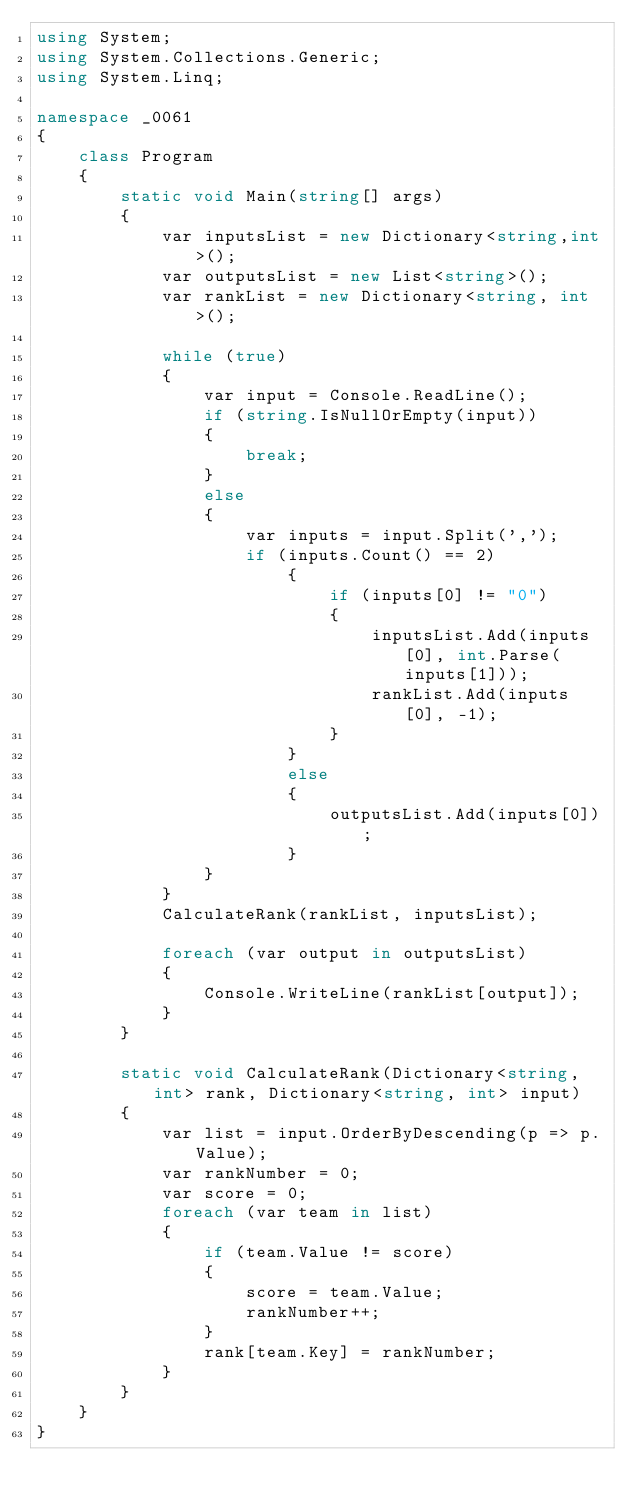Convert code to text. <code><loc_0><loc_0><loc_500><loc_500><_C#_>using System;
using System.Collections.Generic;
using System.Linq;

namespace _0061
{
    class Program
    {
        static void Main(string[] args)
        {
            var inputsList = new Dictionary<string,int>();
            var outputsList = new List<string>();
            var rankList = new Dictionary<string, int>();

            while (true)
            {
                var input = Console.ReadLine();
                if (string.IsNullOrEmpty(input))
                {
                    break;
                }
                else
                {
                    var inputs = input.Split(',');
                    if (inputs.Count() == 2)
                        {
                            if (inputs[0] != "0")
                            {
                                inputsList.Add(inputs[0], int.Parse(inputs[1]));
                                rankList.Add(inputs[0], -1);
                            }
                        }
                        else
                        {
                            outputsList.Add(inputs[0]);
                        }
                }
            }
            CalculateRank(rankList, inputsList);

            foreach (var output in outputsList)
            {
                Console.WriteLine(rankList[output]);
            }
        }

        static void CalculateRank(Dictionary<string, int> rank, Dictionary<string, int> input) 
        {
            var list = input.OrderByDescending(p => p.Value);
            var rankNumber = 0;
            var score = 0;
            foreach (var team in list)
            {
                if (team.Value != score)
                {
                    score = team.Value;
                    rankNumber++;
                }
                rank[team.Key] = rankNumber;
            }        
        }
    }
}</code> 